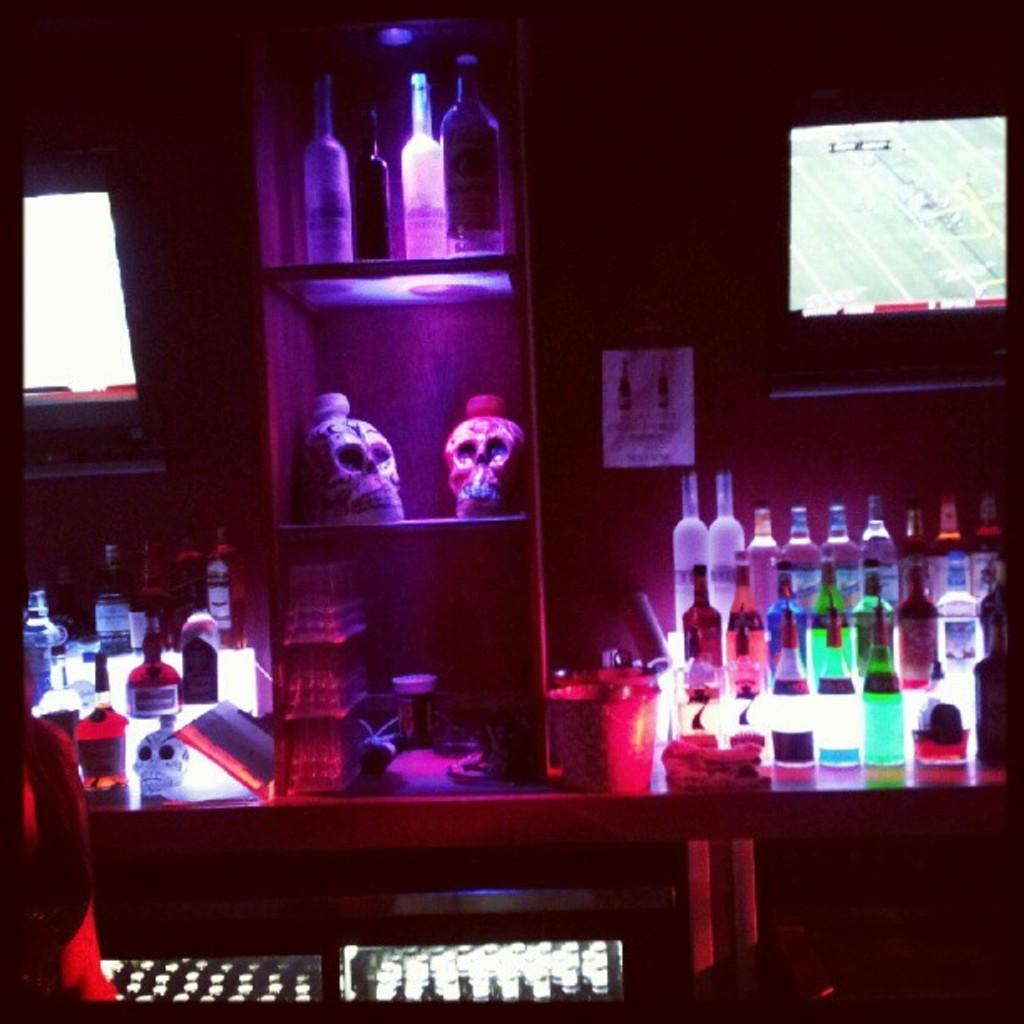What type of setting is depicted in the image? The image contains a bar setting. What can be seen on the desk in the image? There is a small bucket on the desk in the image. What items are related to drinks in the image? There are bottles of drinks in the image. What type of plot is being discussed in the image? There is no plot being discussed in the image, as it is a bar setting and not a conversation or story. 